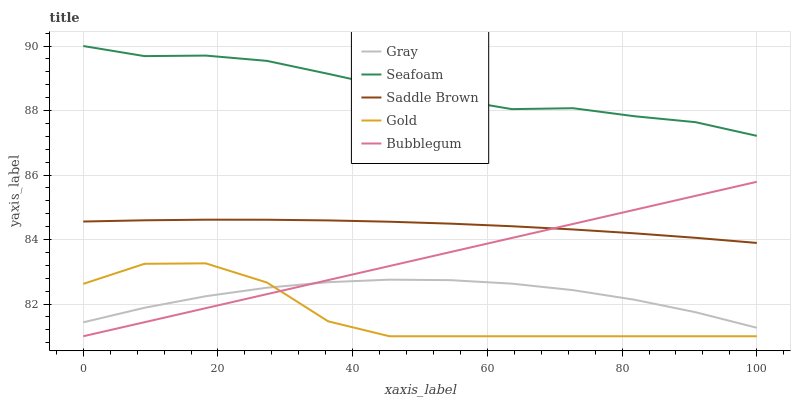Does Gold have the minimum area under the curve?
Answer yes or no. Yes. Does Seafoam have the maximum area under the curve?
Answer yes or no. Yes. Does Bubblegum have the minimum area under the curve?
Answer yes or no. No. Does Bubblegum have the maximum area under the curve?
Answer yes or no. No. Is Bubblegum the smoothest?
Answer yes or no. Yes. Is Gold the roughest?
Answer yes or no. Yes. Is Seafoam the smoothest?
Answer yes or no. No. Is Seafoam the roughest?
Answer yes or no. No. Does Seafoam have the lowest value?
Answer yes or no. No. Does Seafoam have the highest value?
Answer yes or no. Yes. Does Bubblegum have the highest value?
Answer yes or no. No. Is Saddle Brown less than Seafoam?
Answer yes or no. Yes. Is Saddle Brown greater than Gold?
Answer yes or no. Yes. Does Gray intersect Gold?
Answer yes or no. Yes. Is Gray less than Gold?
Answer yes or no. No. Is Gray greater than Gold?
Answer yes or no. No. Does Saddle Brown intersect Seafoam?
Answer yes or no. No. 